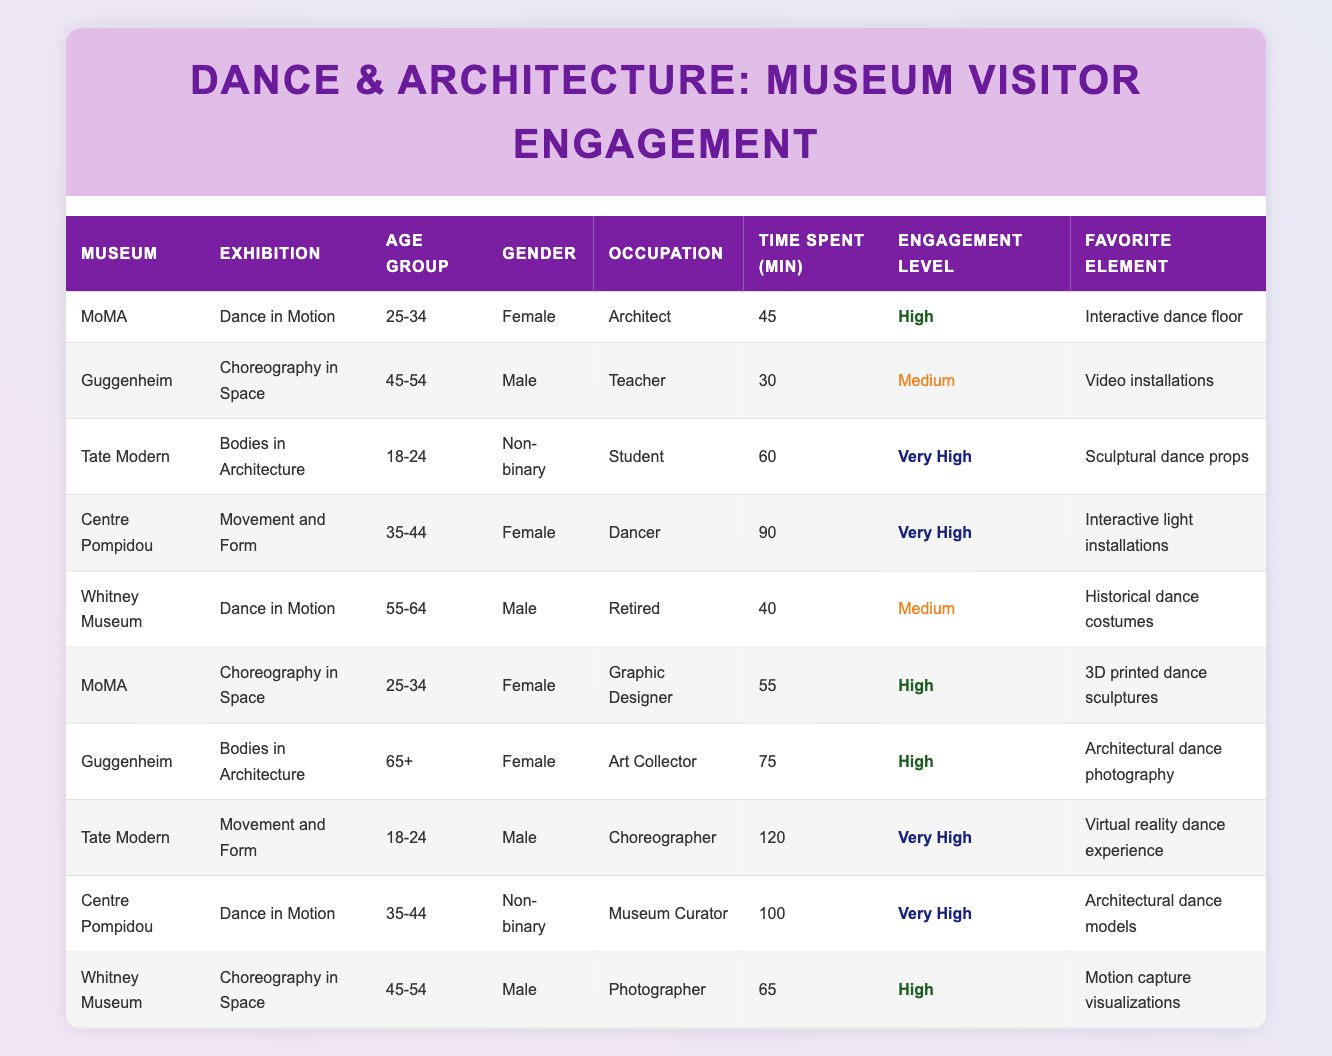What is the engagement level of the visitor who is a dancer at the Centre Pompidou? The dancer at the Centre Pompidou is listed with an engagement level of "Very High" as specified in the table.
Answer: Very High Which exhibition had the highest average time spent by visitors? The individual times spent in minutes are: Dance in Motion (45, 40, 100), Choreography in Space (30, 55, 65), Bodies in Architecture (60, 75), and Movement and Form (90, 120). The average for Dance in Motion is (45 + 40 + 100) / 3 = 61.67, Choreography in Space is (30 + 55 + 65) / 3 = 50, Bodies in Architecture is (60 + 75) / 2 = 67.5, and Movement and Form is (90 + 120) / 2 = 105. The highest average is for Movement and Form, with 105.
Answer: Movement and Form Is there a visitor aged 65+ who had a high engagement level? Yes, there is a visitor aged 65+, who is an art collector at the Guggenheim with an engagement level of "High."
Answer: Yes How many visitors spent more than 70 minutes at a dance exhibition? The visitors who spent more than 70 minutes are: one at the Centre Pompidou (90 minutes), one at Tate Modern (120 minutes), and one at the Centre Pompidou again (100 minutes). This totals three visitors.
Answer: 3 What is the favorite element for the visitor from Tate Modern who identifies as non-binary? The visitor from Tate Modern who identifies as non-binary visited the exhibition "Bodies in Architecture" and their favorite element is "Sculptural dance props," as stated in the table.
Answer: Sculptural dance props Who had the lowest engagement level, and what was their occupation? The visitor with the lowest engagement level is the teacher at the Guggenheim, who had a "Medium" engagement level during their visit to the exhibition "Choreography in Space."
Answer: Teacher Which museum had the highest number of "Very High" engagement levels listed? The table shows that both the Tate Modern and Centre Pompidou have two visitors with "Very High" engagement levels, hence they are tied for the highest count of such engagement levels.
Answer: Tate Modern and Centre Pompidou What percentage of visitors were Female? There are a total of 10 visitors, of which 5 are female (visitor IDs 1, 4, 6, 7, 9). Thus, the percentage is (5/10) * 100 = 50%.
Answer: 50% 